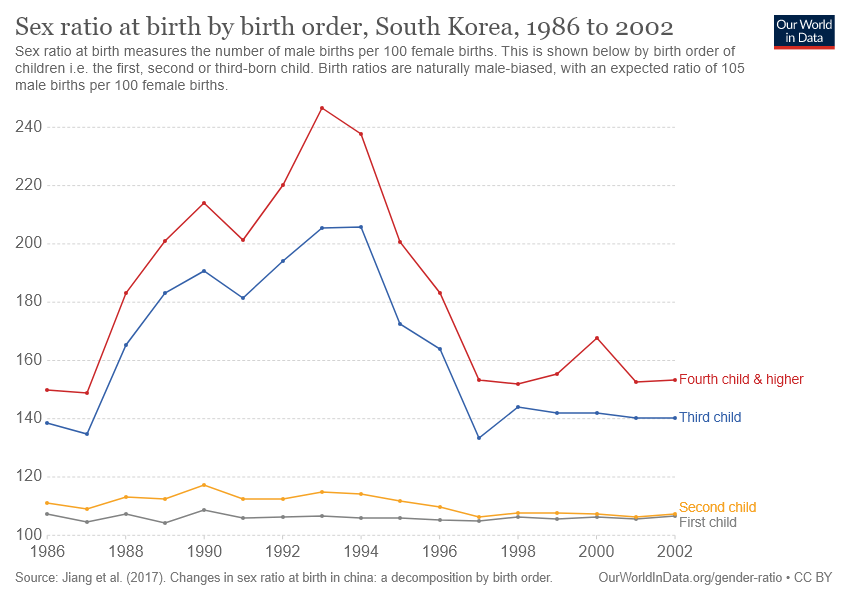Mention a couple of crucial points in this snapshot. The chart shows 4 children. The chart shows a growth and decline in the fourth child and higher educational attainment rates from 1990 to 2018. The highest growth was observed in the 25-29 age group, while the lowest growth was observed in the 65 years and older age group. 